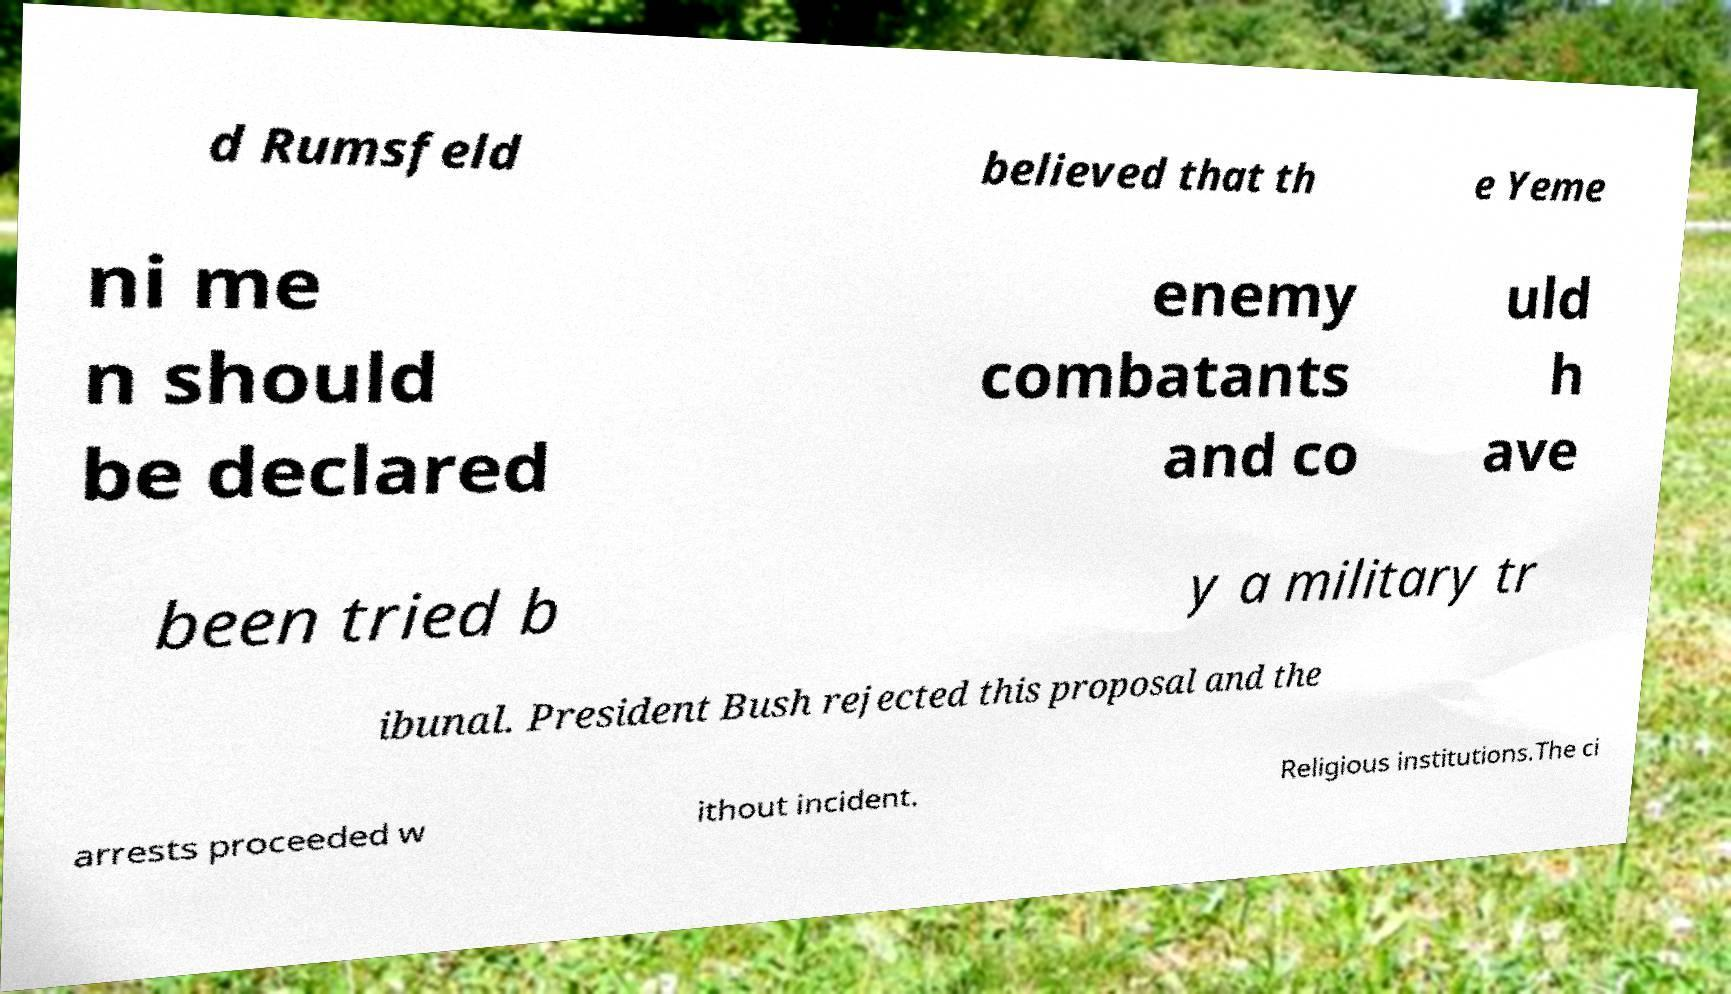For documentation purposes, I need the text within this image transcribed. Could you provide that? d Rumsfeld believed that th e Yeme ni me n should be declared enemy combatants and co uld h ave been tried b y a military tr ibunal. President Bush rejected this proposal and the arrests proceeded w ithout incident. Religious institutions.The ci 